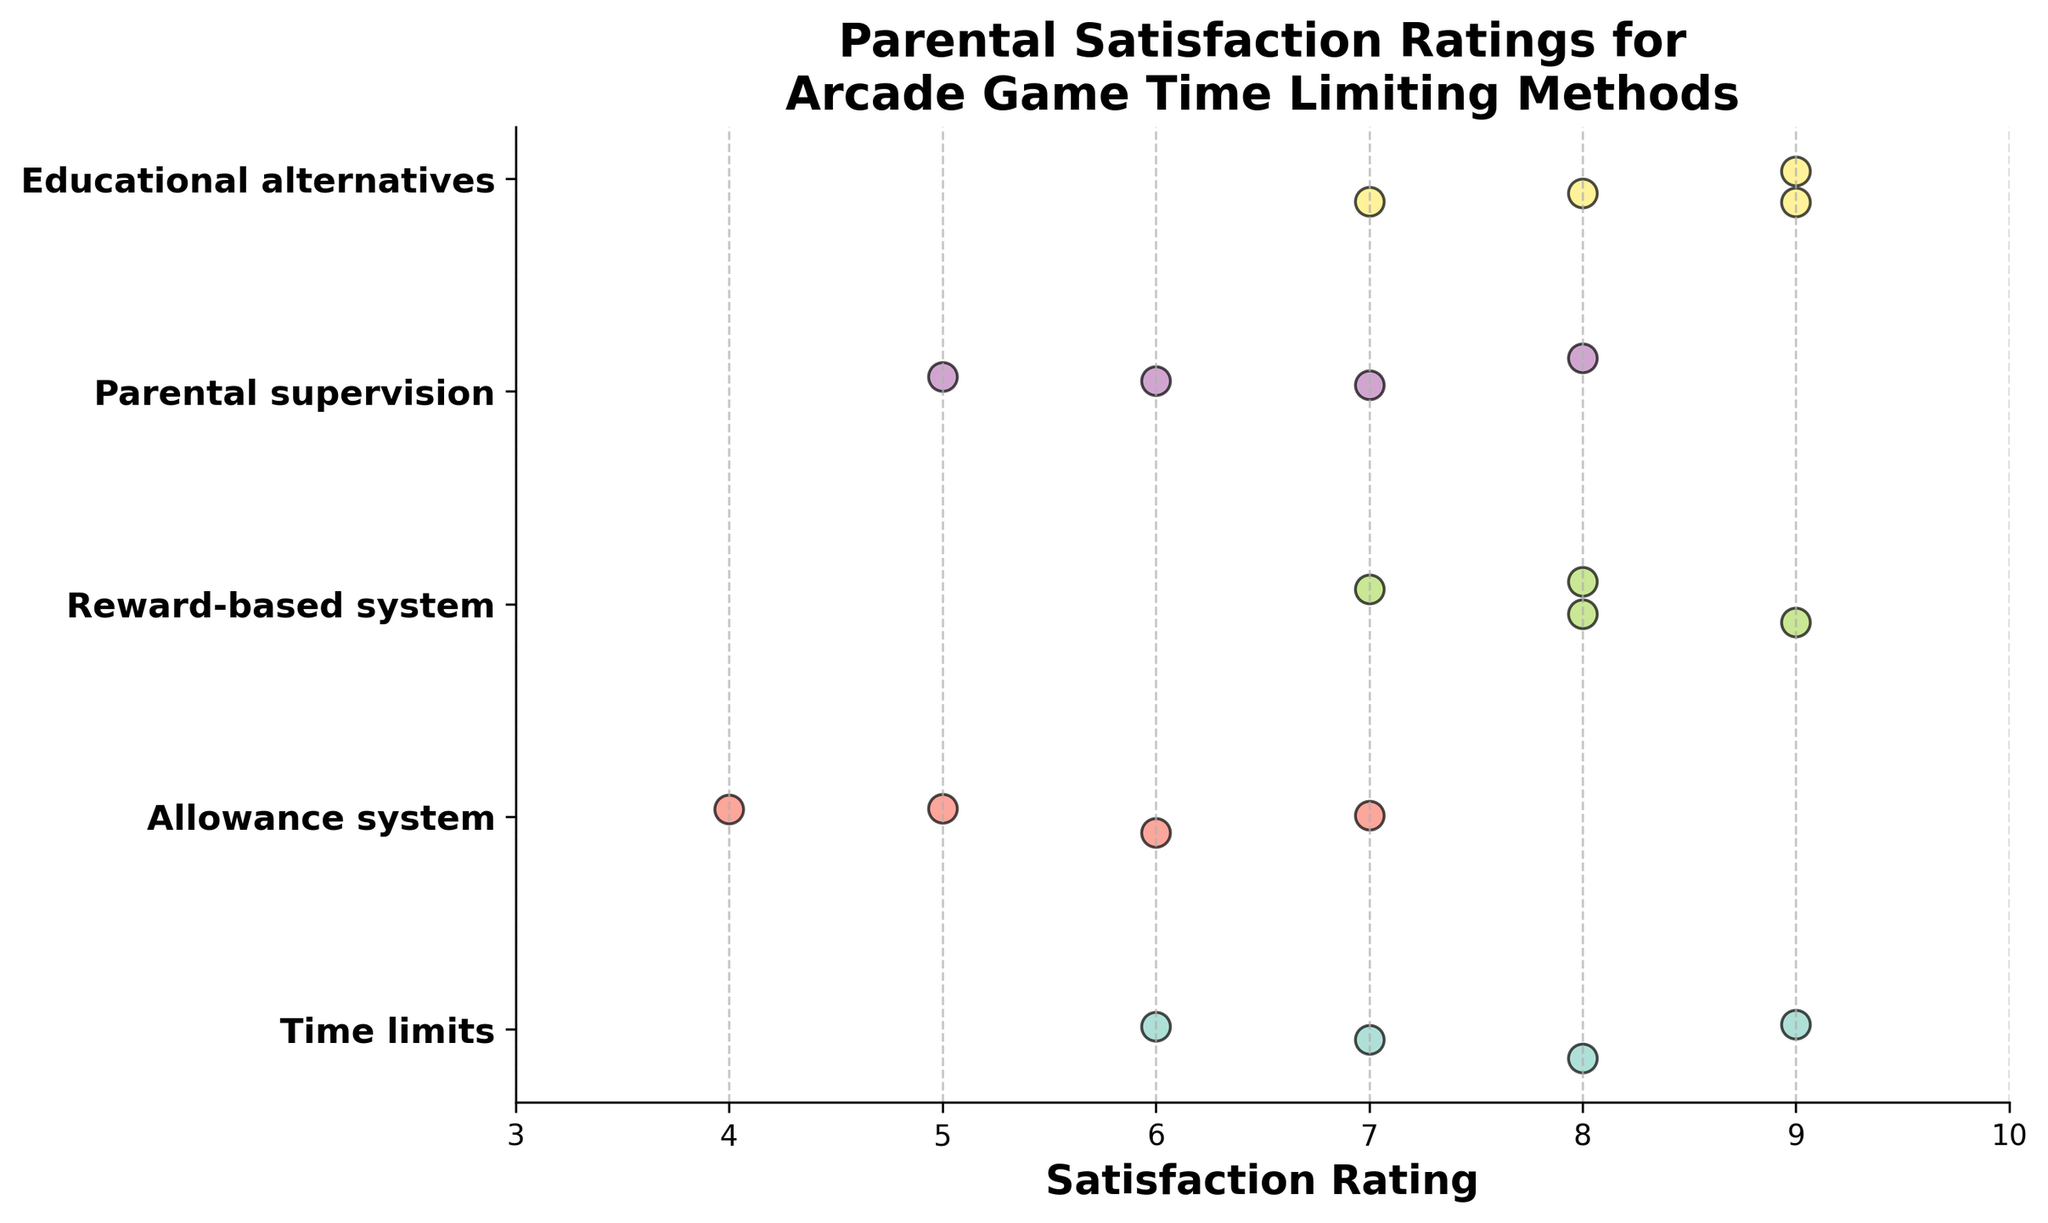Which method received the highest overall satisfaction rating? Based on the data points for each method, Educational alternatives received the highest satisfaction rating of 9 the most times.
Answer: Educational alternatives Which method received the lowest overall satisfaction rating? Allowance system received the lowest satisfaction rating of 4.
Answer: Allowance system How many total data points are there in the plot? Summing the number of data points for each method: Time limits (4), Allowance system (4), Reward-based system (4), Parental supervision (4), Educational alternatives (4) gives a total of 20 data points.
Answer: 20 Which methods have satisfaction ratings that are spread more closely together? The spread of ratings can be observed by the range of satisfaction scores. Time limits (6-9), Allowance system (4-7), Reward-based system (7-9), Parental supervision (5-8), Educational alternatives (7-9). Allowance system has the narrowest spread from 4 to 7.
Answer: Allowance system How does the average satisfaction rating for the reward-based system compare to the average rating for parental supervision? For the reward-based system, the ratings are 8, 9, 7, 8; the average is (8+9+7+8)/4 = 8. For parental supervision, the ratings are 6, 7, 5, 8; the average is (6+7+5+8)/4 = 6.5. Comparing these, the reward-based system has a higher average rating.
Answer: The reward-based system has a higher average rating Which two methods seem to have similar distributions of satisfaction ratings? Observing the spread, Reward-based system (7-9) and Educational alternatives (7-9) have similar distributions with closely clustered high ratings.
Answer: Reward-based system and Educational alternatives How many methods have an average satisfaction rating of 7 or higher? Calculating averages: 
Time limits: (7+8+6+9)/4 = 7.5; 
Allowance system: (5+6+4+7)/4 = 5.5; 
Reward-based system: (8+9+7+8)/4 = 8; 
Parental supervision: (6+7+5+8)/4 = 6.5; 
Educational alternatives: (9+8+7+9)/4 = 8.25. 
Methods with an average of 7 or higher are Time limits, Reward-based system, and Educational alternatives.
Answer: 3 What is the range of satisfaction ratings for parental supervision? The range is calculated as the difference between the highest and lowest ratings. For parental supervision, ratings are 6, 7, 5, 8. The range is 8-5 = 3.
Answer: 3 Which method has the most significant variability in satisfaction ratings? Variability can be assessed by the range of satisfaction scores. Allowance system has ratings of 5, 6, 4, 7 with a range of 3, which is the highest variability.
Answer: Allowance system What is the median satisfaction rating for time limits? Ratings for Time limits are 7, 8, 6, 9. Arranging them in order: 6, 7, 8, 9. The median value, in this case, is the average of the two middle numbers (7+8)/2 = 7.5.
Answer: 7.5 